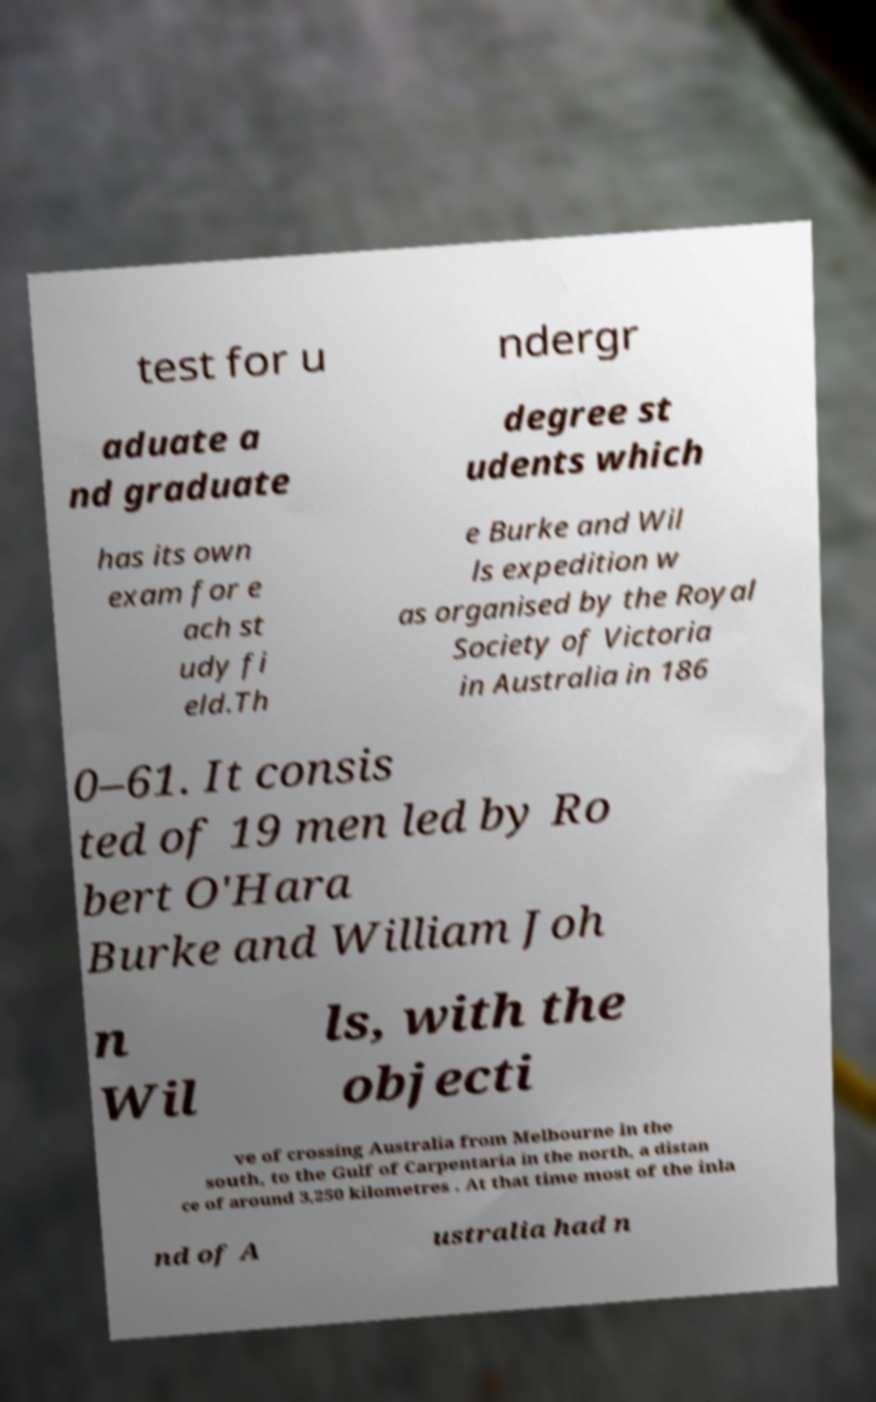Can you read and provide the text displayed in the image?This photo seems to have some interesting text. Can you extract and type it out for me? test for u ndergr aduate a nd graduate degree st udents which has its own exam for e ach st udy fi eld.Th e Burke and Wil ls expedition w as organised by the Royal Society of Victoria in Australia in 186 0–61. It consis ted of 19 men led by Ro bert O'Hara Burke and William Joh n Wil ls, with the objecti ve of crossing Australia from Melbourne in the south, to the Gulf of Carpentaria in the north, a distan ce of around 3,250 kilometres . At that time most of the inla nd of A ustralia had n 